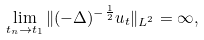Convert formula to latex. <formula><loc_0><loc_0><loc_500><loc_500>\lim _ { t _ { n } \to t _ { 1 } } \| ( - \Delta ) ^ { - \frac { 1 } { 2 } } u _ { t } \| _ { L ^ { 2 } } = \infty ,</formula> 